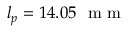Convert formula to latex. <formula><loc_0><loc_0><loc_500><loc_500>l _ { p } = 1 4 . 0 5 m m</formula> 